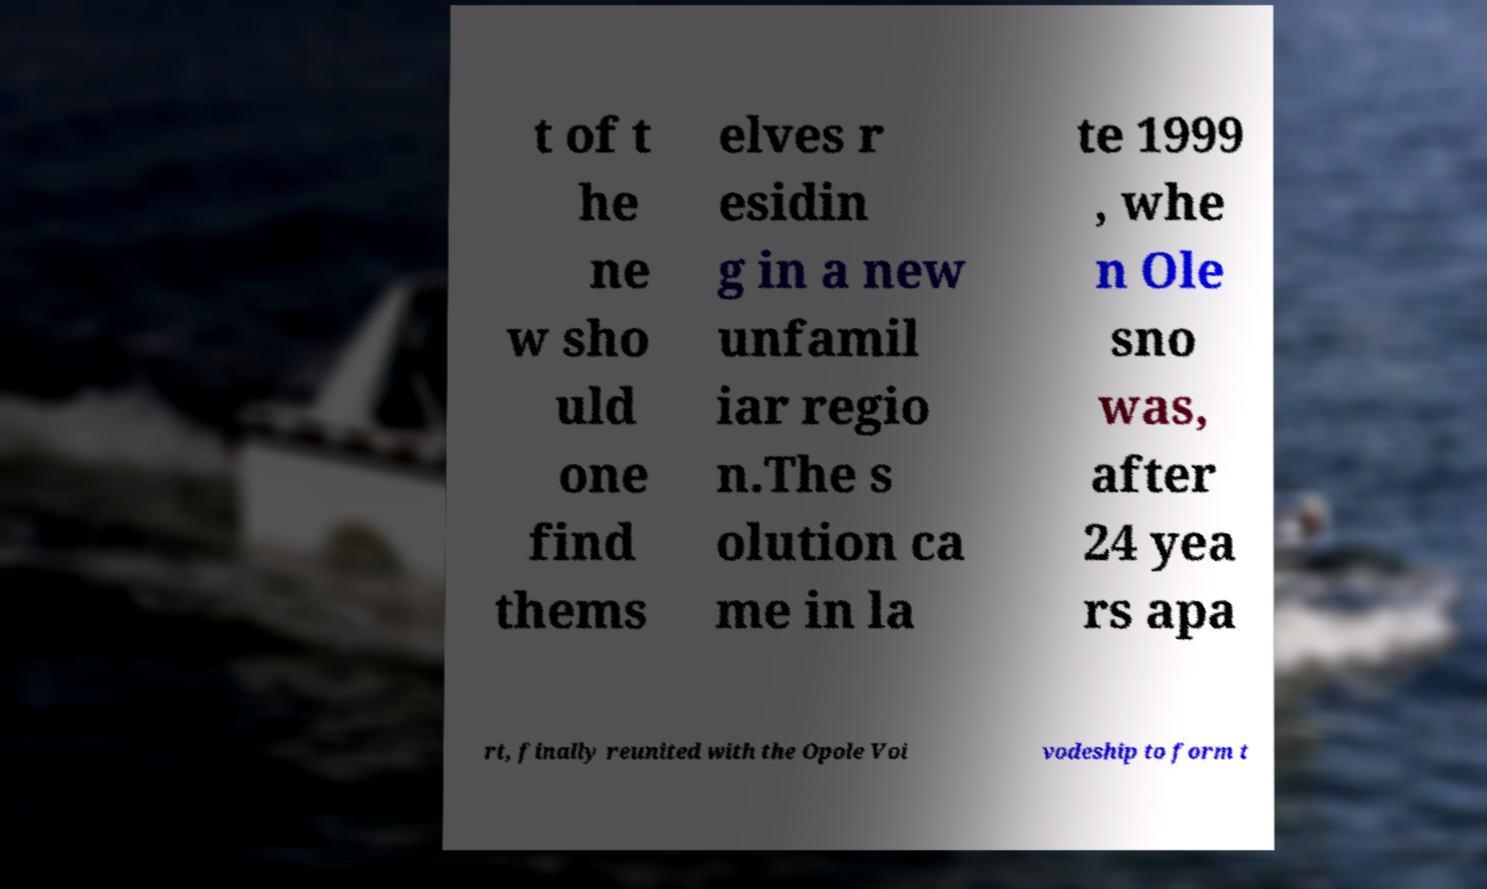Can you read and provide the text displayed in the image?This photo seems to have some interesting text. Can you extract and type it out for me? t of t he ne w sho uld one find thems elves r esidin g in a new unfamil iar regio n.The s olution ca me in la te 1999 , whe n Ole sno was, after 24 yea rs apa rt, finally reunited with the Opole Voi vodeship to form t 